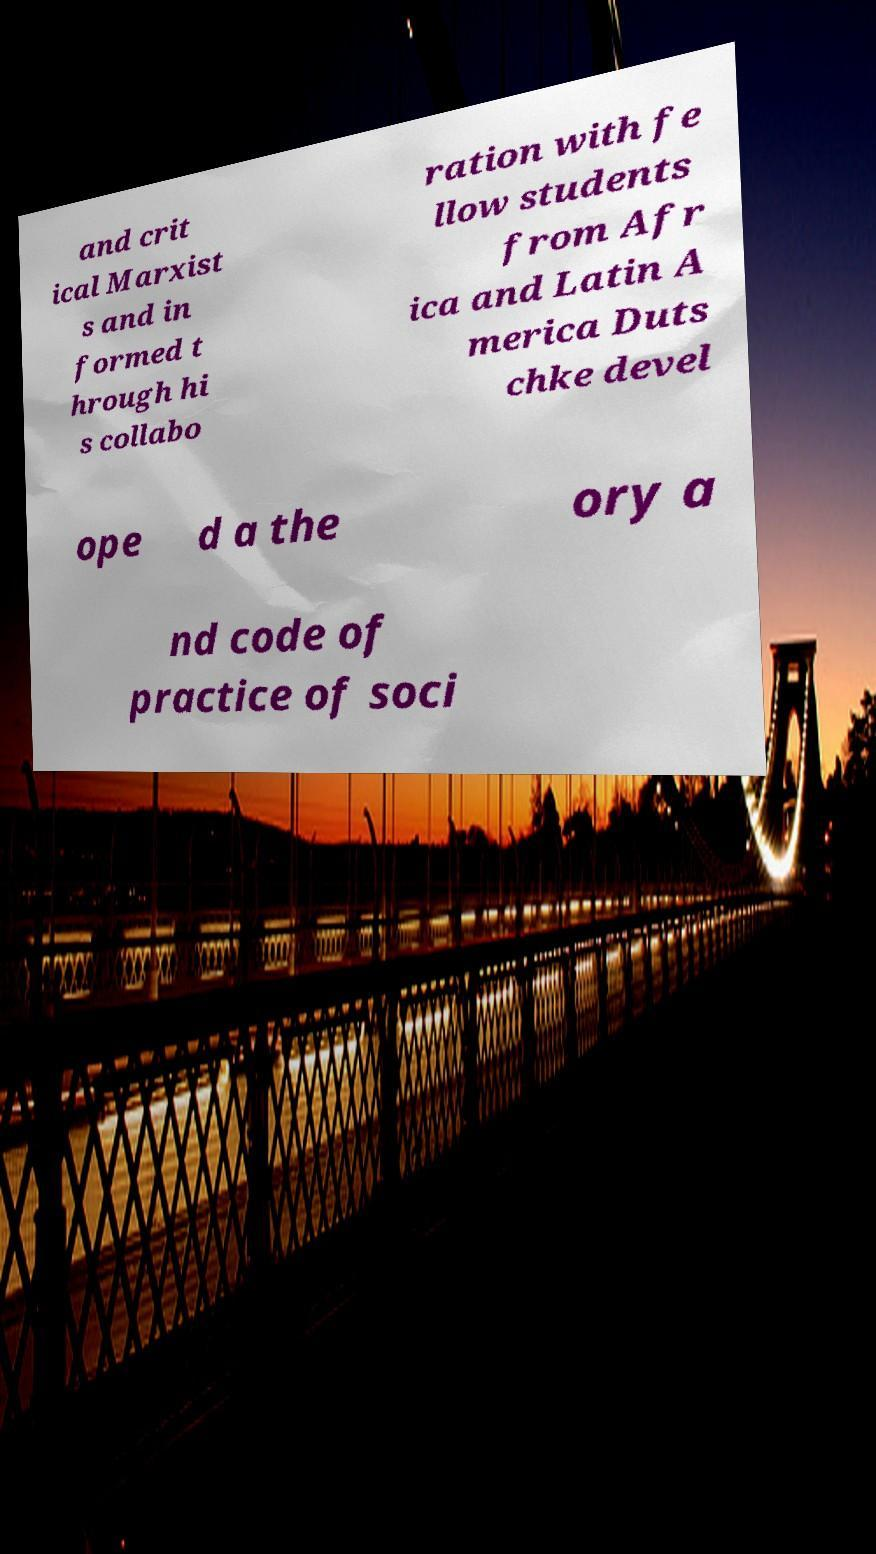Can you accurately transcribe the text from the provided image for me? and crit ical Marxist s and in formed t hrough hi s collabo ration with fe llow students from Afr ica and Latin A merica Duts chke devel ope d a the ory a nd code of practice of soci 